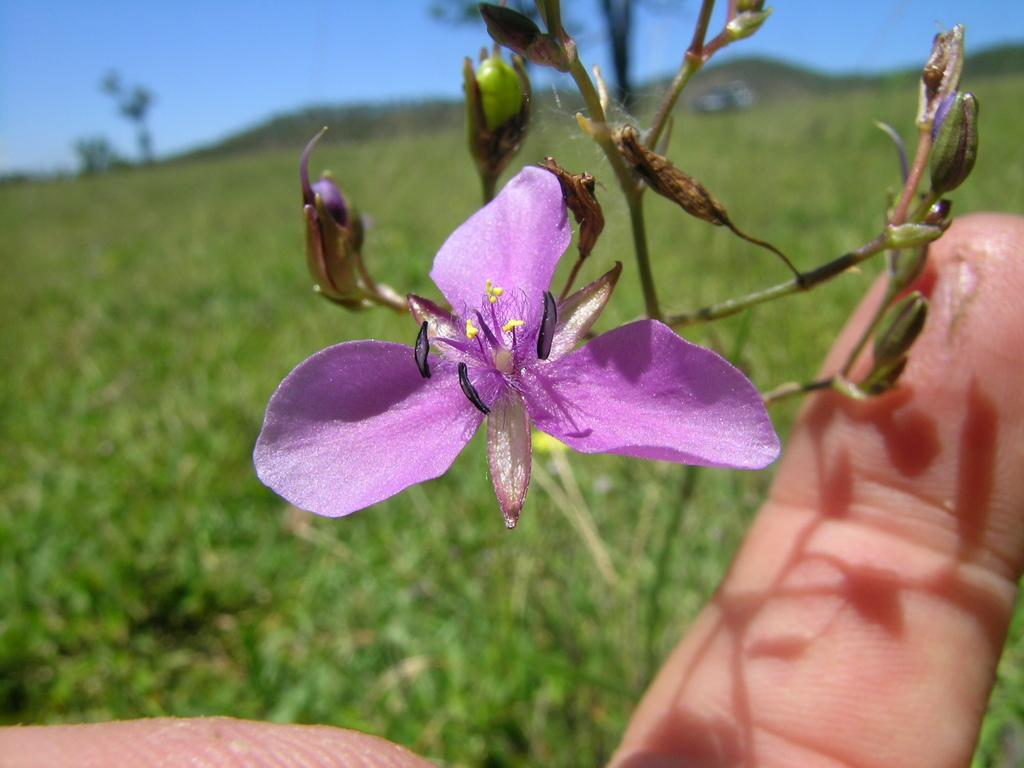What is the main subject of the image? There is a flower in the image. What part of a person can be seen in the image? A human hand is visible in the image. What type of vegetation is present in the background of the image? There is grass in the background of the image. What can be seen in the distance in the image? The sky is visible in the background of the image. What type of thread is being used to support the growth of the flower in the image? There is no thread present in the image, and the flower's growth is not supported by any visible means. 